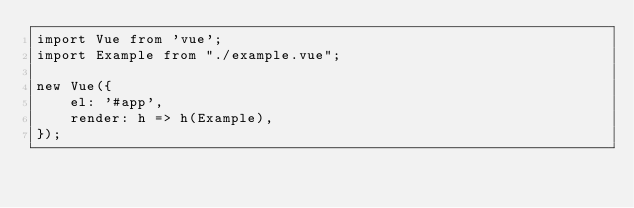Convert code to text. <code><loc_0><loc_0><loc_500><loc_500><_JavaScript_>import Vue from 'vue';
import Example from "./example.vue";

new Vue({
    el: '#app',
    render: h => h(Example),
});
</code> 